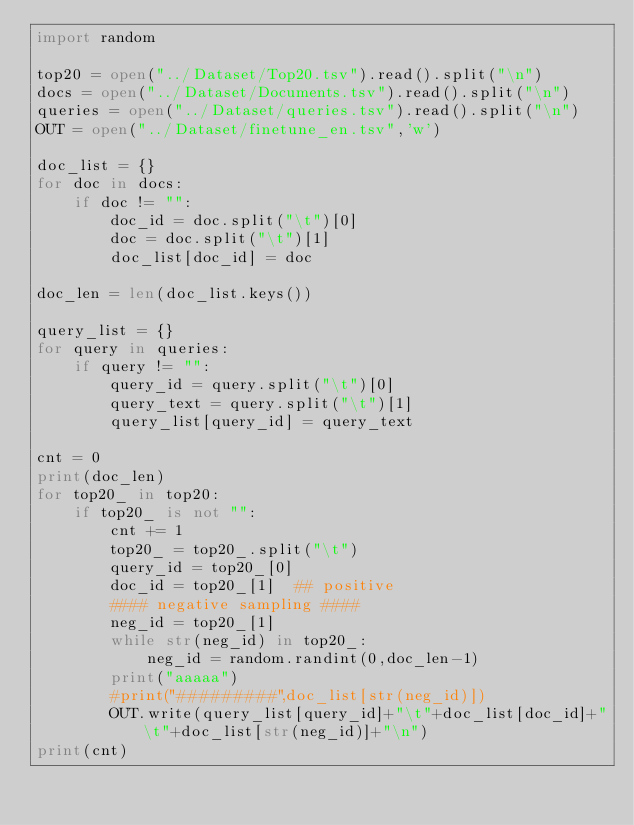<code> <loc_0><loc_0><loc_500><loc_500><_Python_>import random

top20 = open("../Dataset/Top20.tsv").read().split("\n")
docs = open("../Dataset/Documents.tsv").read().split("\n")
queries = open("../Dataset/queries.tsv").read().split("\n")
OUT = open("../Dataset/finetune_en.tsv",'w')

doc_list = {}
for doc in docs:
    if doc != "":
        doc_id = doc.split("\t")[0]
        doc = doc.split("\t")[1]
        doc_list[doc_id] = doc

doc_len = len(doc_list.keys())

query_list = {}
for query in queries:
    if query != "":
        query_id = query.split("\t")[0]
        query_text = query.split("\t")[1]
        query_list[query_id] = query_text

cnt = 0
print(doc_len)
for top20_ in top20:
    if top20_ is not "":
        cnt += 1
        top20_ = top20_.split("\t")
        query_id = top20_[0]
        doc_id = top20_[1]  ## positive
        #### negative sampling ####
        neg_id = top20_[1]
        while str(neg_id) in top20_:
            neg_id = random.randint(0,doc_len-1)
        print("aaaaa")
        #print("#########",doc_list[str(neg_id)])
        OUT.write(query_list[query_id]+"\t"+doc_list[doc_id]+"\t"+doc_list[str(neg_id)]+"\n")
print(cnt)
</code> 